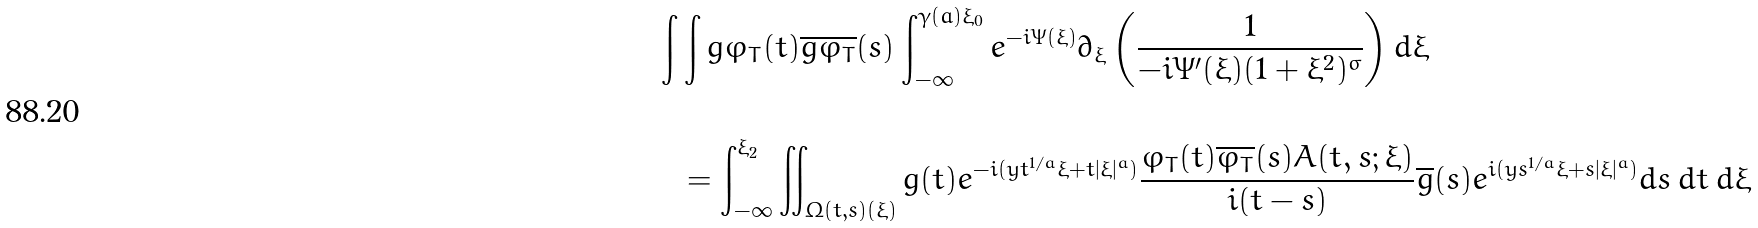Convert formula to latex. <formula><loc_0><loc_0><loc_500><loc_500>\int & \int g \varphi _ { T } ( t ) \overline { g \varphi _ { T } } ( s ) \int _ { - \infty } ^ { \gamma ( a ) \xi _ { 0 } } e ^ { - i \Psi ( \xi ) } \partial _ { \xi } \left ( \frac { 1 } { - i \Psi ^ { \prime } ( \xi ) ( 1 + \xi ^ { 2 } ) ^ { \sigma } } \right ) d \xi \\ & \\ & = \int _ { - \infty } ^ { \xi _ { 2 } } \iint _ { \Omega ( t , s ) ( \xi ) } g ( t ) e ^ { - i ( y t ^ { 1 / a } \xi + t | \xi | ^ { a } ) } \frac { \varphi _ { T } ( t ) \overline { \varphi _ { T } } ( s ) A ( t , s ; \xi ) } { i ( t - s ) } \overline { g } ( s ) e ^ { i ( y s ^ { 1 / a } \xi + s | \xi | ^ { a } ) } d s \, d t \, d \xi</formula> 